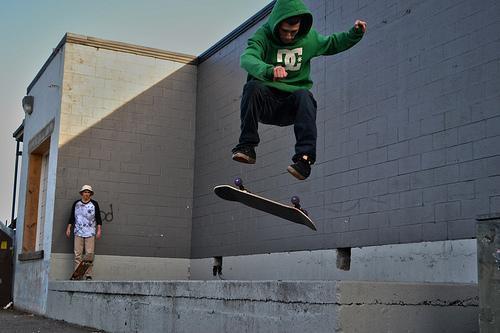How many people are in the picture?
Give a very brief answer. 2. 